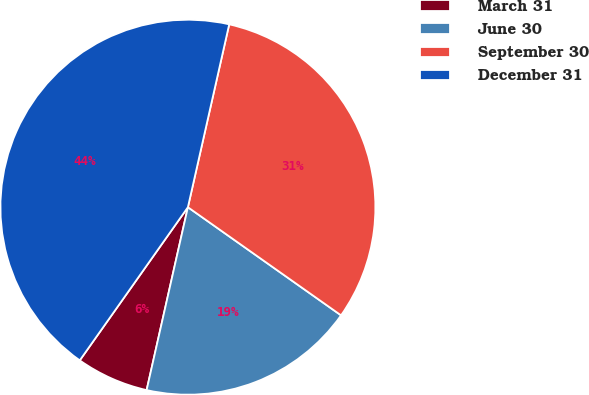Convert chart. <chart><loc_0><loc_0><loc_500><loc_500><pie_chart><fcel>March 31<fcel>June 30<fcel>September 30<fcel>December 31<nl><fcel>6.25%<fcel>18.75%<fcel>31.25%<fcel>43.75%<nl></chart> 